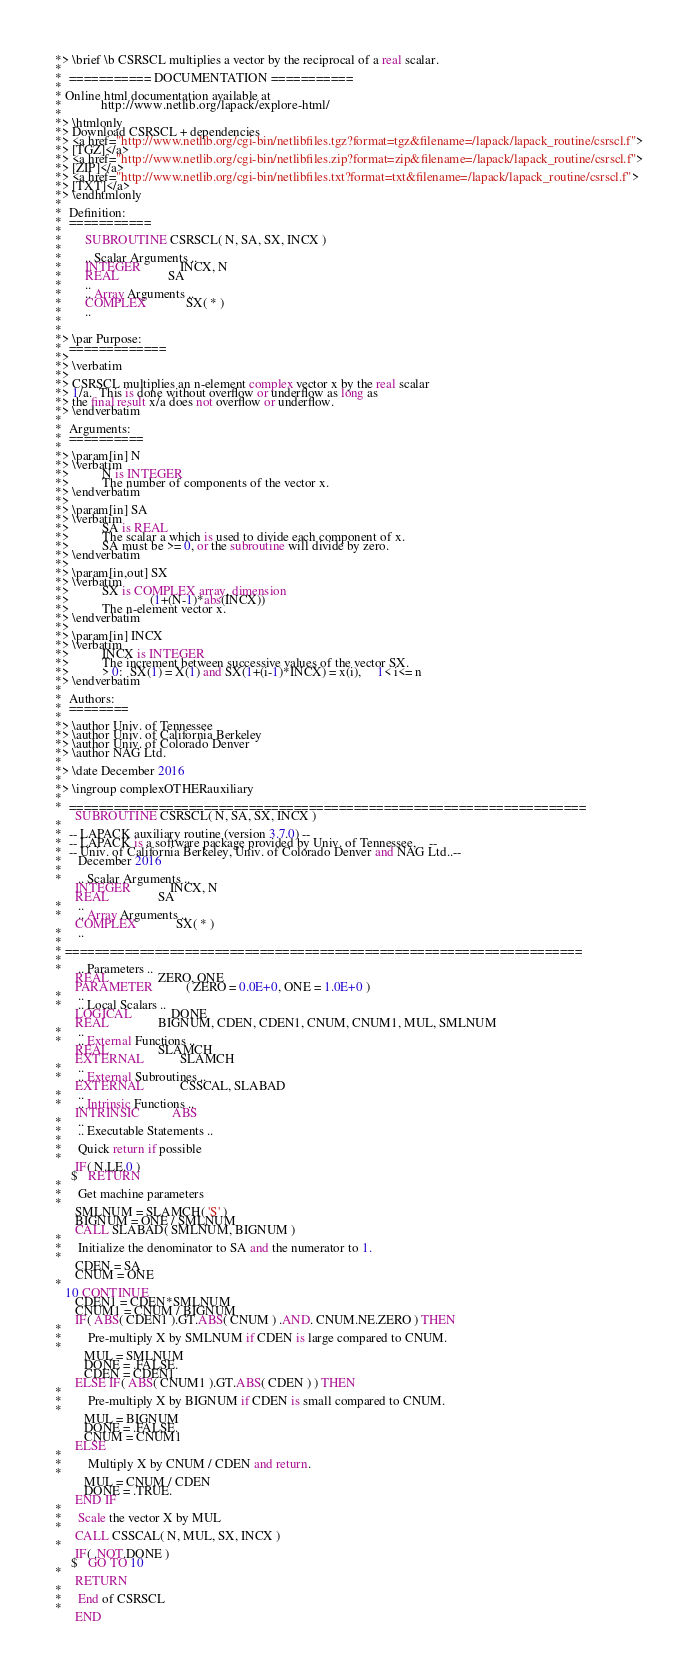Convert code to text. <code><loc_0><loc_0><loc_500><loc_500><_FORTRAN_>*> \brief \b CSRSCL multiplies a vector by the reciprocal of a real scalar.
*
*  =========== DOCUMENTATION ===========
*
* Online html documentation available at
*            http://www.netlib.org/lapack/explore-html/
*
*> \htmlonly
*> Download CSRSCL + dependencies
*> <a href="http://www.netlib.org/cgi-bin/netlibfiles.tgz?format=tgz&filename=/lapack/lapack_routine/csrscl.f">
*> [TGZ]</a>
*> <a href="http://www.netlib.org/cgi-bin/netlibfiles.zip?format=zip&filename=/lapack/lapack_routine/csrscl.f">
*> [ZIP]</a>
*> <a href="http://www.netlib.org/cgi-bin/netlibfiles.txt?format=txt&filename=/lapack/lapack_routine/csrscl.f">
*> [TXT]</a>
*> \endhtmlonly
*
*  Definition:
*  ===========
*
*       SUBROUTINE CSRSCL( N, SA, SX, INCX )
*
*       .. Scalar Arguments ..
*       INTEGER            INCX, N
*       REAL               SA
*       ..
*       .. Array Arguments ..
*       COMPLEX            SX( * )
*       ..
*
*
*> \par Purpose:
*  =============
*>
*> \verbatim
*>
*> CSRSCL multiplies an n-element complex vector x by the real scalar
*> 1/a.  This is done without overflow or underflow as long as
*> the final result x/a does not overflow or underflow.
*> \endverbatim
*
*  Arguments:
*  ==========
*
*> \param[in] N
*> \verbatim
*>          N is INTEGER
*>          The number of components of the vector x.
*> \endverbatim
*>
*> \param[in] SA
*> \verbatim
*>          SA is REAL
*>          The scalar a which is used to divide each component of x.
*>          SA must be >= 0, or the subroutine will divide by zero.
*> \endverbatim
*>
*> \param[in,out] SX
*> \verbatim
*>          SX is COMPLEX array, dimension
*>                         (1+(N-1)*abs(INCX))
*>          The n-element vector x.
*> \endverbatim
*>
*> \param[in] INCX
*> \verbatim
*>          INCX is INTEGER
*>          The increment between successive values of the vector SX.
*>          > 0:  SX(1) = X(1) and SX(1+(i-1)*INCX) = x(i),     1< i<= n
*> \endverbatim
*
*  Authors:
*  ========
*
*> \author Univ. of Tennessee
*> \author Univ. of California Berkeley
*> \author Univ. of Colorado Denver
*> \author NAG Ltd.
*
*> \date December 2016
*
*> \ingroup complexOTHERauxiliary
*
*  =====================================================================
      SUBROUTINE CSRSCL( N, SA, SX, INCX )
*
*  -- LAPACK auxiliary routine (version 3.7.0) --
*  -- LAPACK is a software package provided by Univ. of Tennessee,    --
*  -- Univ. of California Berkeley, Univ. of Colorado Denver and NAG Ltd..--
*     December 2016
*
*     .. Scalar Arguments ..
      INTEGER            INCX, N
      REAL               SA
*     ..
*     .. Array Arguments ..
      COMPLEX            SX( * )
*     ..
*
* =====================================================================
*
*     .. Parameters ..
      REAL               ZERO, ONE
      PARAMETER          ( ZERO = 0.0E+0, ONE = 1.0E+0 )
*     ..
*     .. Local Scalars ..
      LOGICAL            DONE
      REAL               BIGNUM, CDEN, CDEN1, CNUM, CNUM1, MUL, SMLNUM
*     ..
*     .. External Functions ..
      REAL               SLAMCH
      EXTERNAL           SLAMCH
*     ..
*     .. External Subroutines ..
      EXTERNAL           CSSCAL, SLABAD
*     ..
*     .. Intrinsic Functions ..
      INTRINSIC          ABS
*     ..
*     .. Executable Statements ..
*
*     Quick return if possible
*
      IF( N.LE.0 )
     $   RETURN
*
*     Get machine parameters
*
      SMLNUM = SLAMCH( 'S' )
      BIGNUM = ONE / SMLNUM
      CALL SLABAD( SMLNUM, BIGNUM )
*
*     Initialize the denominator to SA and the numerator to 1.
*
      CDEN = SA
      CNUM = ONE
*
   10 CONTINUE
      CDEN1 = CDEN*SMLNUM
      CNUM1 = CNUM / BIGNUM
      IF( ABS( CDEN1 ).GT.ABS( CNUM ) .AND. CNUM.NE.ZERO ) THEN
*
*        Pre-multiply X by SMLNUM if CDEN is large compared to CNUM.
*
         MUL = SMLNUM
         DONE = .FALSE.
         CDEN = CDEN1
      ELSE IF( ABS( CNUM1 ).GT.ABS( CDEN ) ) THEN
*
*        Pre-multiply X by BIGNUM if CDEN is small compared to CNUM.
*
         MUL = BIGNUM
         DONE = .FALSE.
         CNUM = CNUM1
      ELSE
*
*        Multiply X by CNUM / CDEN and return.
*
         MUL = CNUM / CDEN
         DONE = .TRUE.
      END IF
*
*     Scale the vector X by MUL
*
      CALL CSSCAL( N, MUL, SX, INCX )
*
      IF( .NOT.DONE )
     $   GO TO 10
*
      RETURN
*
*     End of CSRSCL
*
      END
</code> 